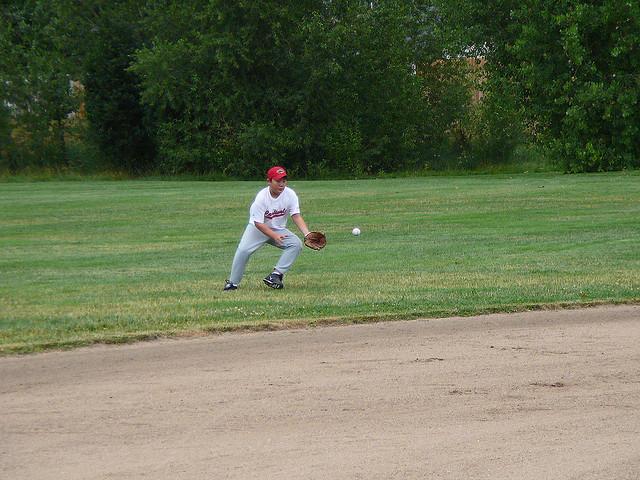What is this person doing with the ball?
Answer briefly. Catching. Is the boy catching the ball?
Give a very brief answer. Yes. Is he wearing a motorbike outfit?
Give a very brief answer. No. Is this a professional baseball diamond?
Keep it brief. No. Is this player in the infield or outfield?
Quick response, please. Outfield. What is the man catching?
Quick response, please. Baseball. What is the boy doing?
Concise answer only. Catching. What color is the hat?
Keep it brief. Red. 